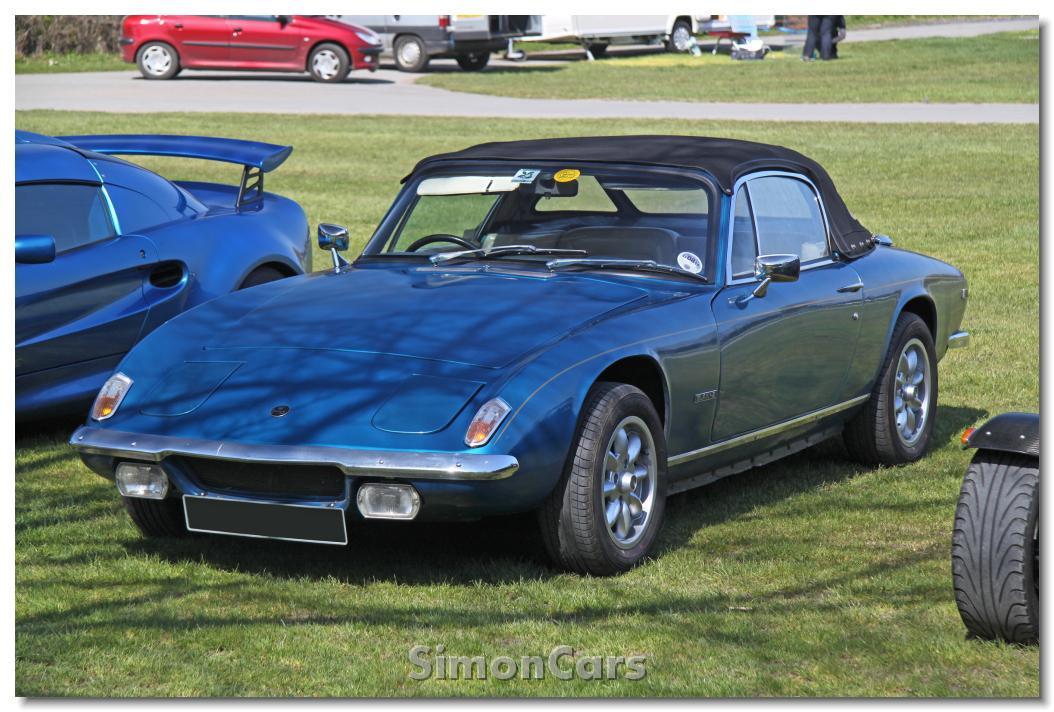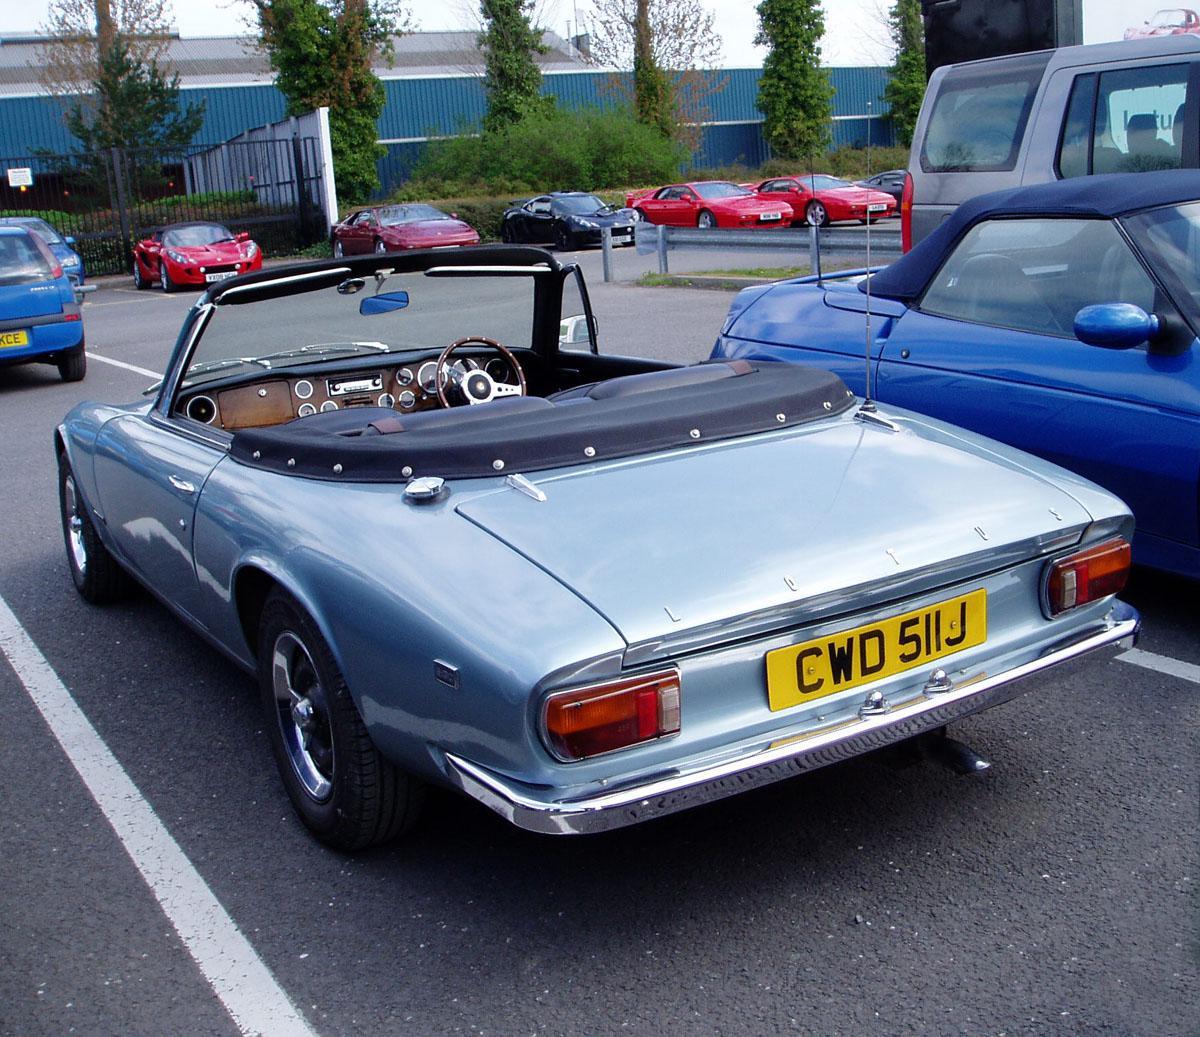The first image is the image on the left, the second image is the image on the right. For the images shown, is this caption "One image shows a blue convertible with the top down." true? Answer yes or no. Yes. The first image is the image on the left, the second image is the image on the right. Evaluate the accuracy of this statement regarding the images: "In one image, at least one car is parked on a brick pavement.". Is it true? Answer yes or no. No. 